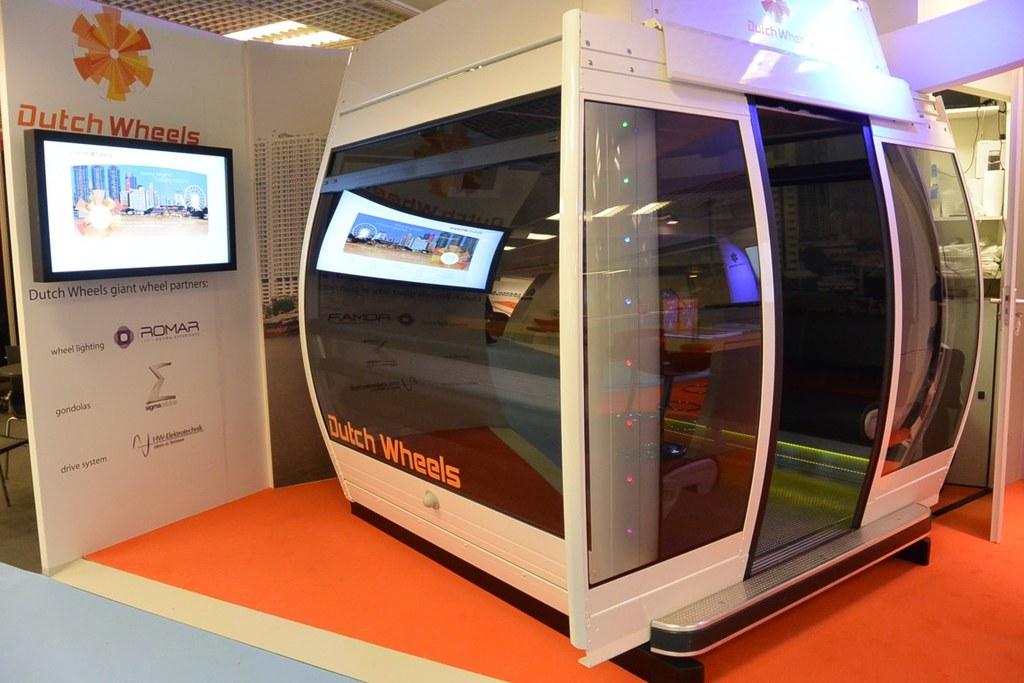What is the name of the machine?
Offer a very short reply. Dutch wheels. What brand is listed for wheel lighting?
Give a very brief answer. Dutch wheels. 